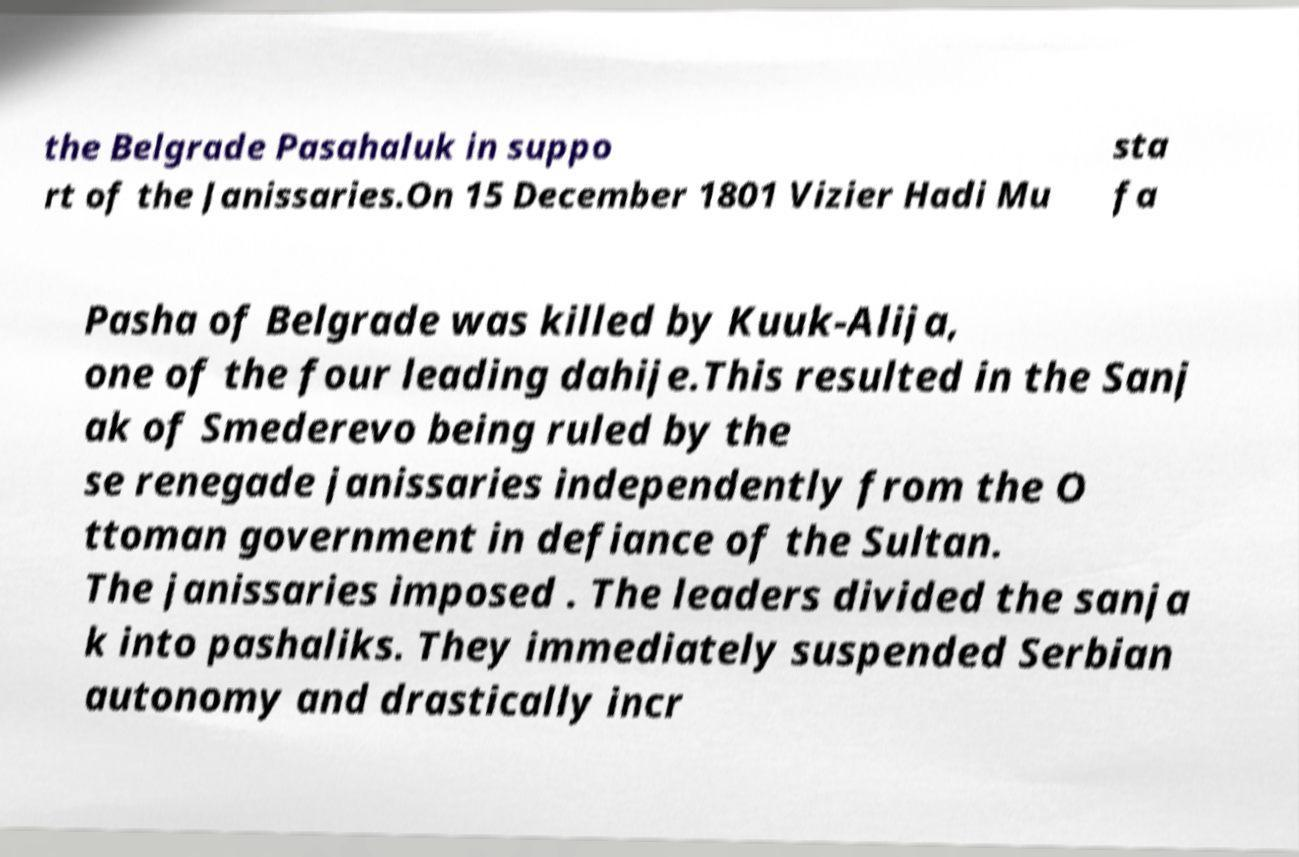Please read and relay the text visible in this image. What does it say? the Belgrade Pasahaluk in suppo rt of the Janissaries.On 15 December 1801 Vizier Hadi Mu sta fa Pasha of Belgrade was killed by Kuuk-Alija, one of the four leading dahije.This resulted in the Sanj ak of Smederevo being ruled by the se renegade janissaries independently from the O ttoman government in defiance of the Sultan. The janissaries imposed . The leaders divided the sanja k into pashaliks. They immediately suspended Serbian autonomy and drastically incr 